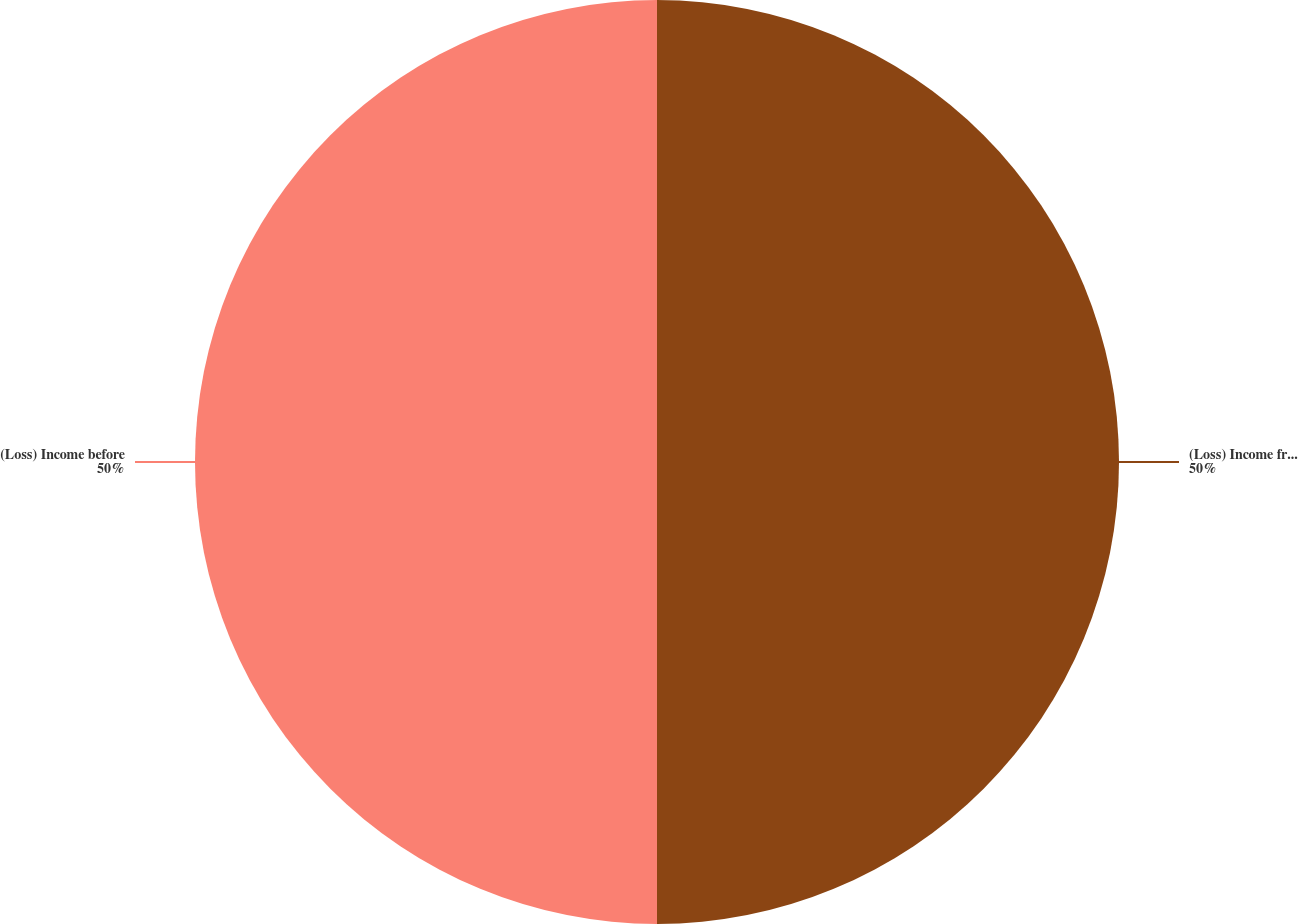<chart> <loc_0><loc_0><loc_500><loc_500><pie_chart><fcel>(Loss) Income from Continuing<fcel>(Loss) Income before<nl><fcel>50.0%<fcel>50.0%<nl></chart> 